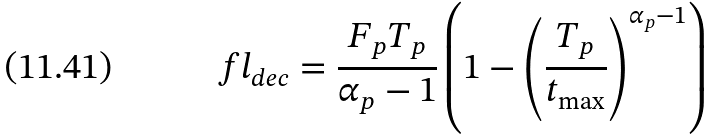Convert formula to latex. <formula><loc_0><loc_0><loc_500><loc_500>f l _ { d e c } = \frac { F _ { p } T _ { p } } { \alpha _ { p } - 1 } \left ( 1 - \left ( \frac { T _ { p } } { t _ { \max } } \right ) ^ { \alpha _ { p } - 1 } \right )</formula> 